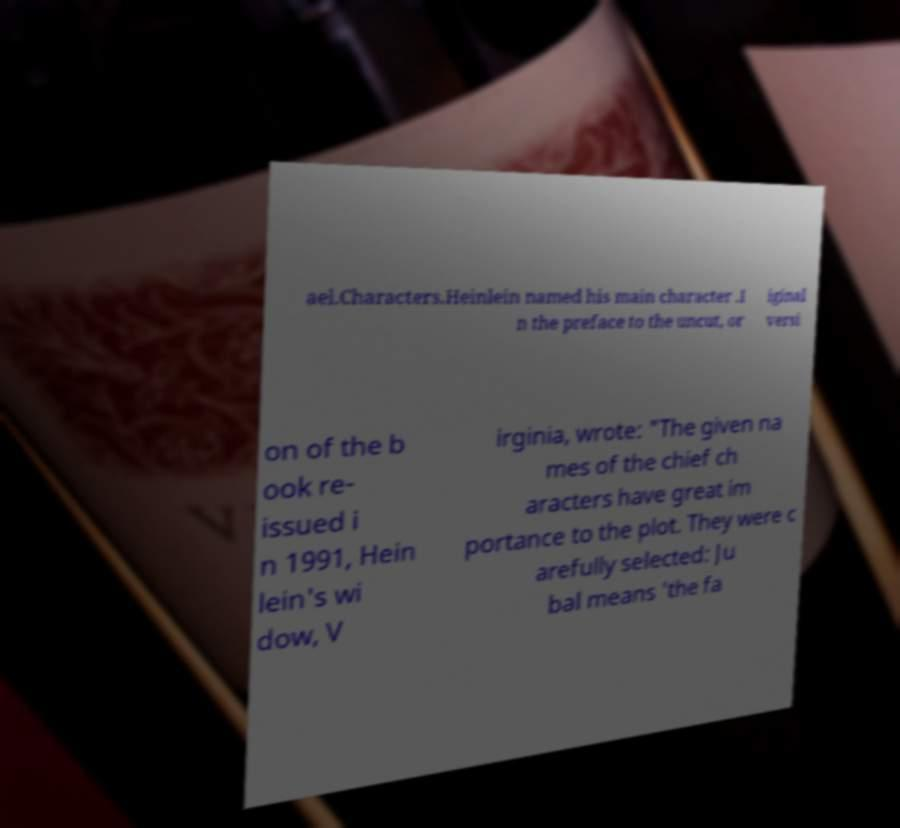Could you assist in decoding the text presented in this image and type it out clearly? ael.Characters.Heinlein named his main character .I n the preface to the uncut, or iginal versi on of the b ook re- issued i n 1991, Hein lein's wi dow, V irginia, wrote: "The given na mes of the chief ch aracters have great im portance to the plot. They were c arefully selected: Ju bal means 'the fa 